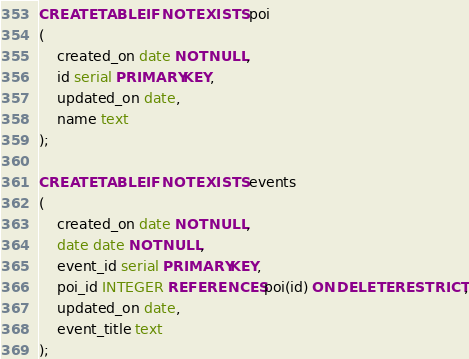Convert code to text. <code><loc_0><loc_0><loc_500><loc_500><_SQL_>CREATE TABLE IF NOT EXISTS poi
(
    created_on date NOT NULL,
    id serial PRIMARY KEY,
    updated_on date,
    name text
);

CREATE TABLE IF NOT EXISTS events
(
    created_on date NOT NULL,
    date date NOT NULL,
    event_id serial PRIMARY KEY,
    poi_id INTEGER REFERENCES poi(id) ON DELETE RESTRICT,
    updated_on date,
    event_title text
);
</code> 